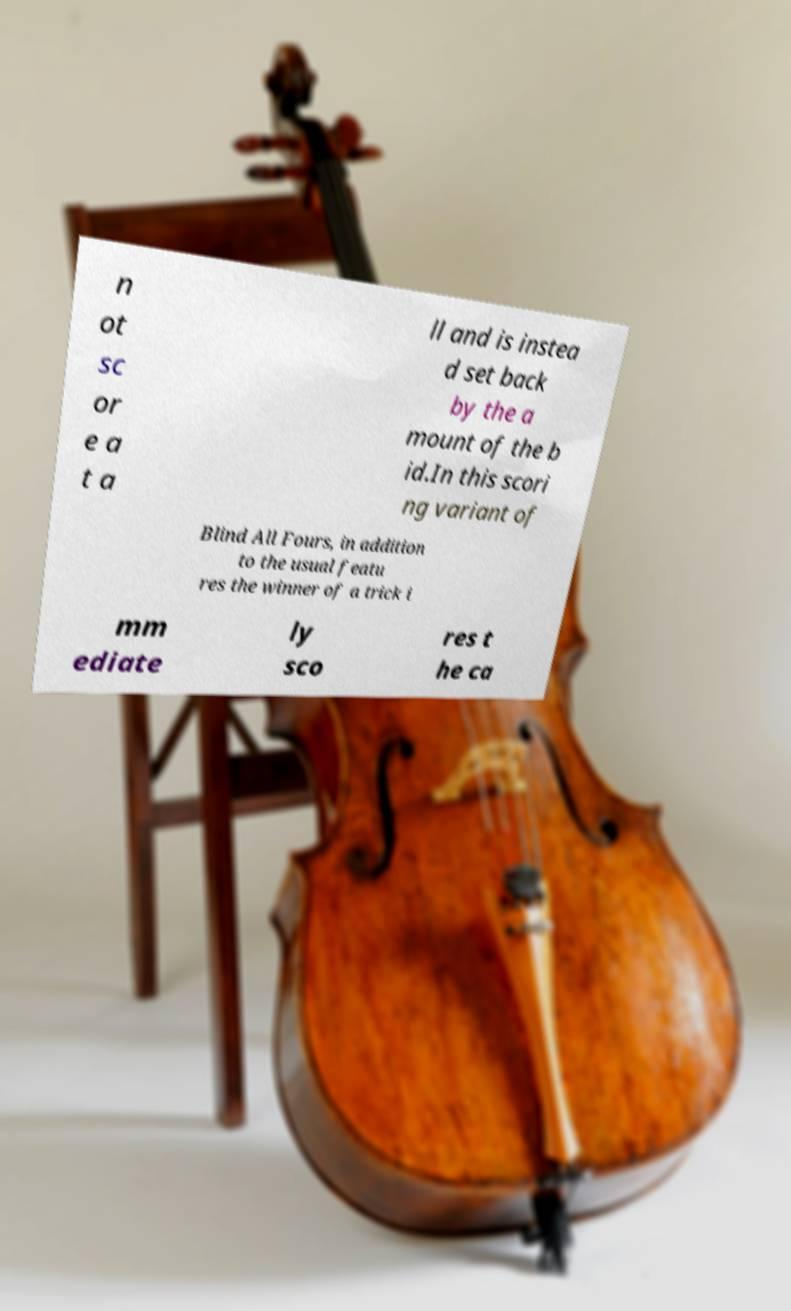Please identify and transcribe the text found in this image. n ot sc or e a t a ll and is instea d set back by the a mount of the b id.In this scori ng variant of Blind All Fours, in addition to the usual featu res the winner of a trick i mm ediate ly sco res t he ca 